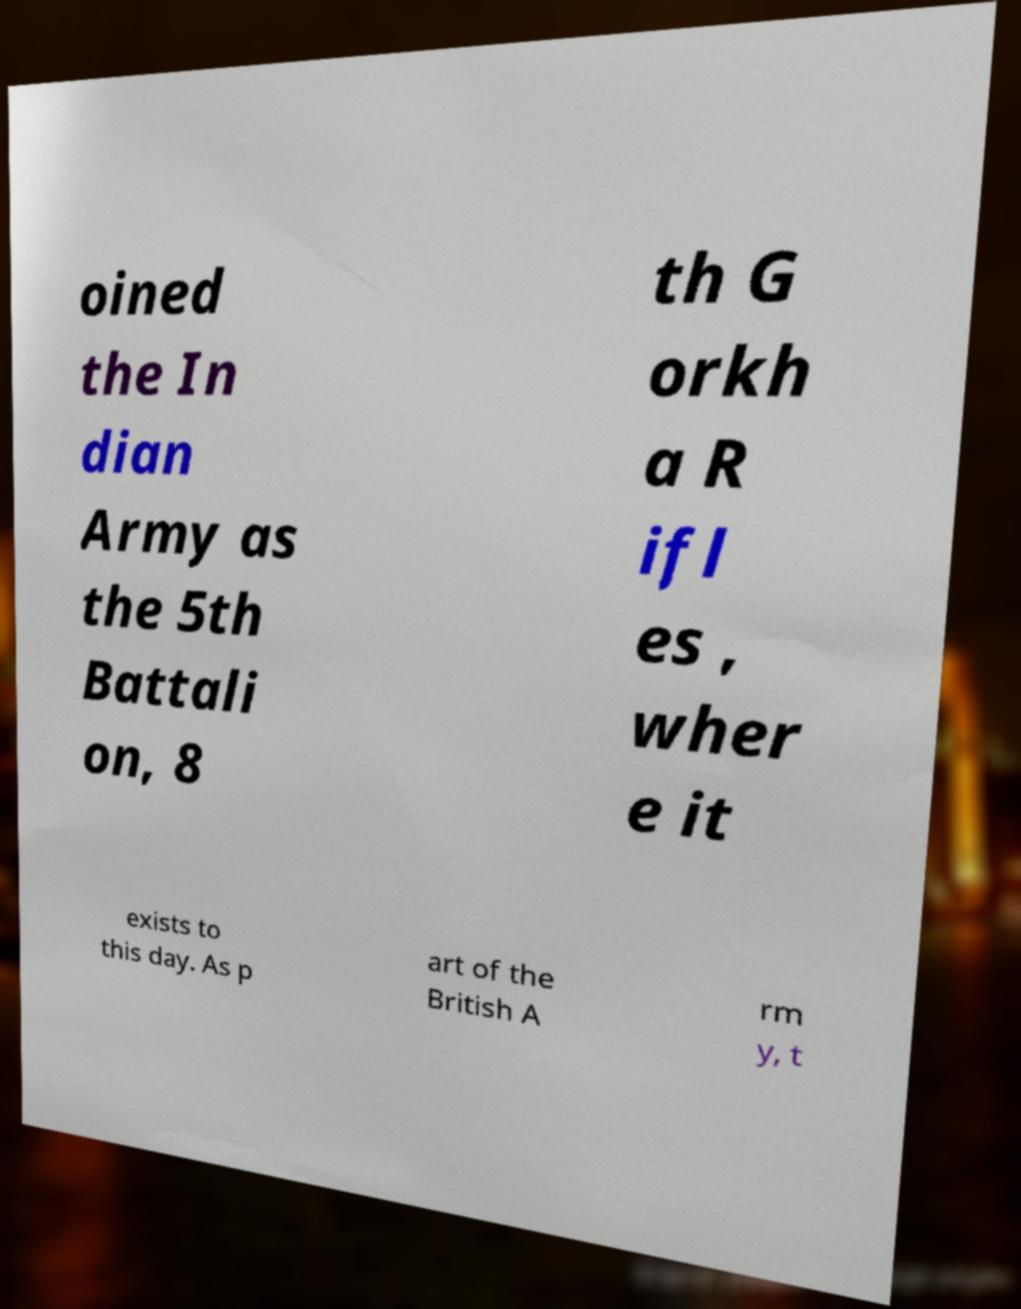Could you assist in decoding the text presented in this image and type it out clearly? oined the In dian Army as the 5th Battali on, 8 th G orkh a R ifl es , wher e it exists to this day. As p art of the British A rm y, t 